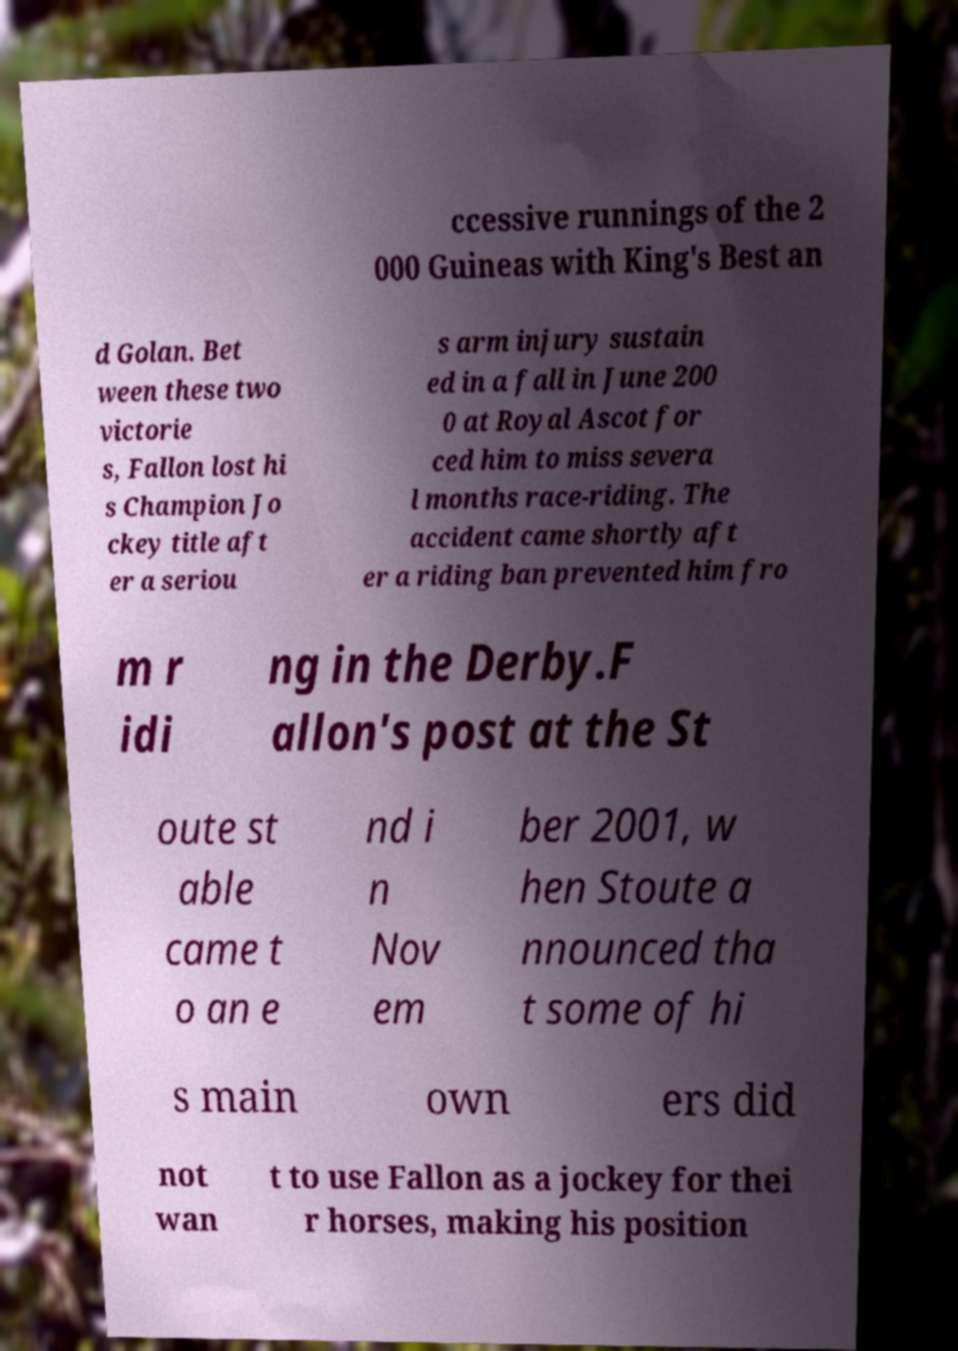Could you assist in decoding the text presented in this image and type it out clearly? ccessive runnings of the 2 000 Guineas with King's Best an d Golan. Bet ween these two victorie s, Fallon lost hi s Champion Jo ckey title aft er a seriou s arm injury sustain ed in a fall in June 200 0 at Royal Ascot for ced him to miss severa l months race-riding. The accident came shortly aft er a riding ban prevented him fro m r idi ng in the Derby.F allon's post at the St oute st able came t o an e nd i n Nov em ber 2001, w hen Stoute a nnounced tha t some of hi s main own ers did not wan t to use Fallon as a jockey for thei r horses, making his position 